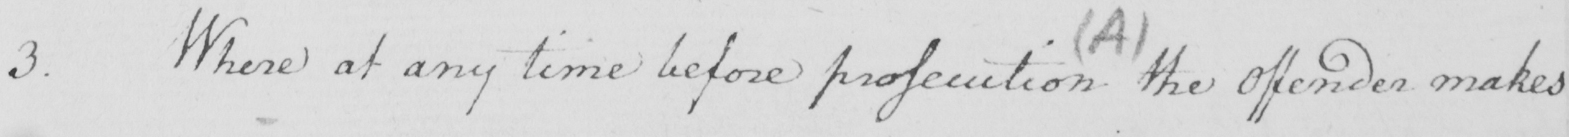Transcribe the text shown in this historical manuscript line. 3 . Where at any time before prosecution the offender makes 